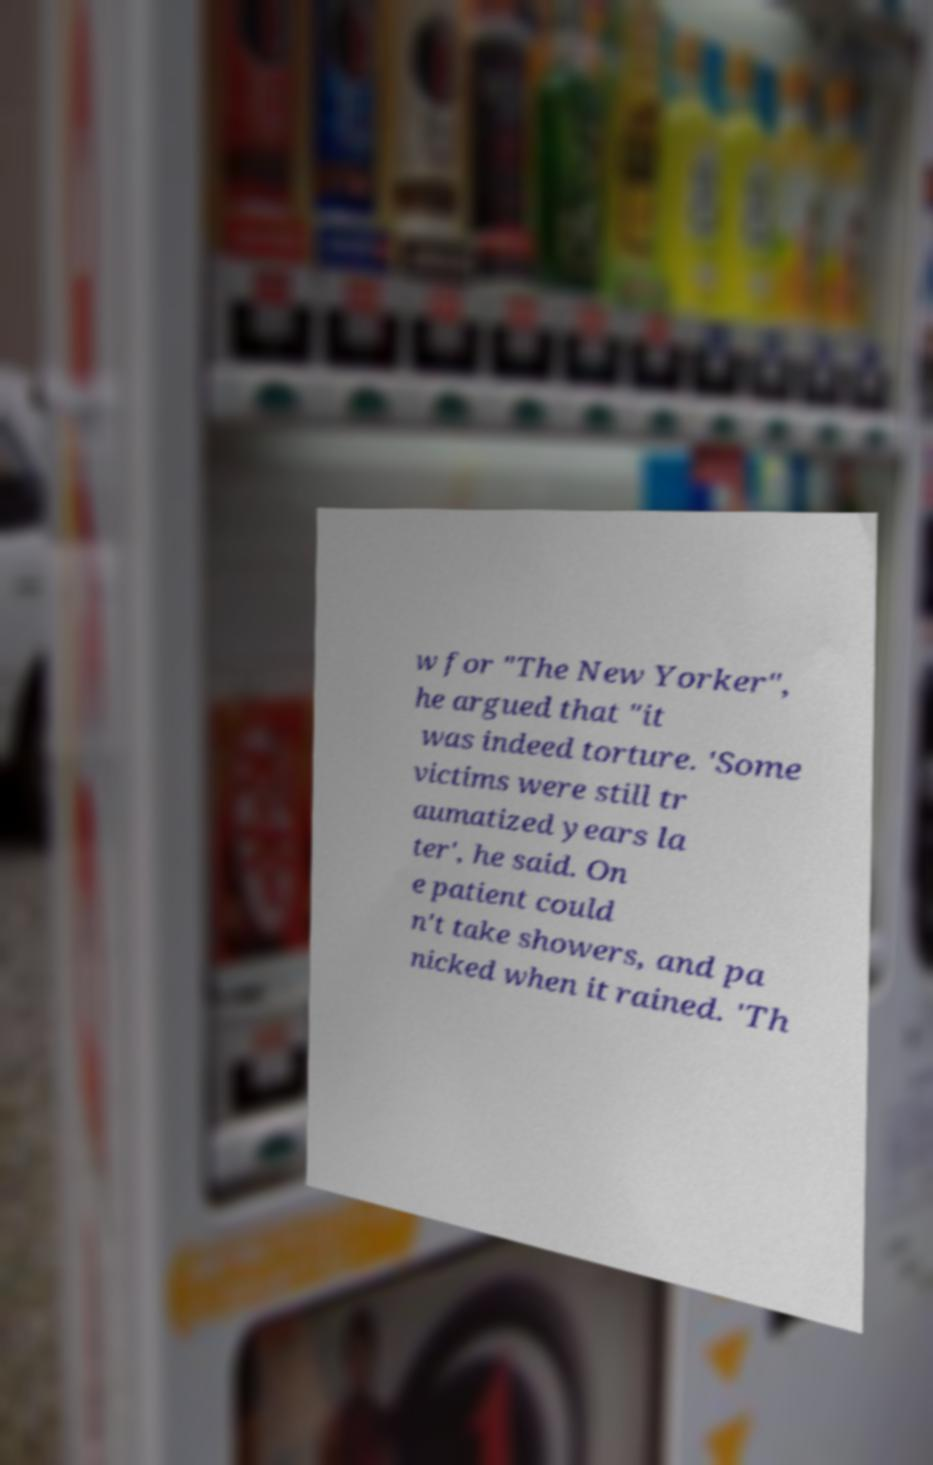Please read and relay the text visible in this image. What does it say? w for "The New Yorker", he argued that "it was indeed torture. 'Some victims were still tr aumatized years la ter', he said. On e patient could n't take showers, and pa nicked when it rained. 'Th 